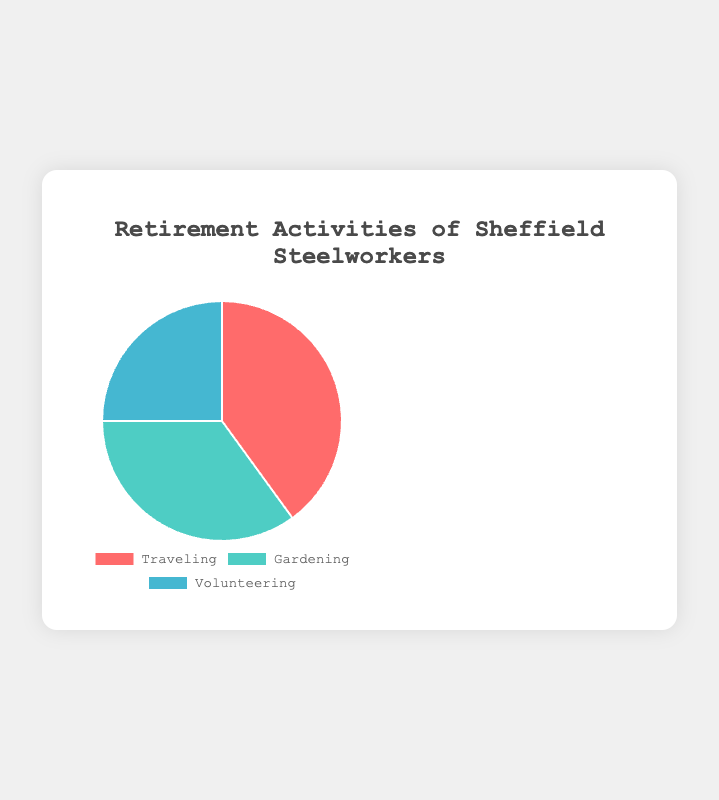Which activity is most popular among retired steelworkers? From the pie chart, the largest section is the one labeled "Traveling", which represents the highest percentage at 40%.
Answer: Traveling Which activity is least popular among retired steelworkers? The smallest section of the pie chart is labeled "Volunteering", which represents the lowest percentage at 25%.
Answer: Volunteering How many more percentage points is Traveling compared to Volunteering? Traveling is at 40% and Volunteering is at 25%. The difference is 40% - 25% = 15%.
Answer: 15% Is the percentage of people gardening greater than those volunteering? Yes, the percentage of people gardening (35%) is greater than those volunteering (25%).
Answer: Yes What is the sum of percentages for Gardening and Volunteering? Gardening is 35% and Volunteering is 25%. Adding these gives 35% + 25% = 60%.
Answer: 60% Which activity categories are represented by a shade of green or blue? The colors associated with Gardening and Volunteering are green and blue respectively from the visual attributes in the pie chart.
Answer: Gardening, Volunteering Which two activities combined make up less than half of the retired steelworkers' preferences? Gardening and Volunteering combined are 35% + 25% = 60%, so the pair with less than half is Traveling and Volunteering with 40% + 25% = 65%. The only combination less than half is by single gardening, so 35%.
Answer: None; All pair combinations exceed half Is Gardening closer in percentage to Traveling or Volunteering? The difference between Gardening (35%) and Traveling (40%) is 5%, whereas the difference between Gardening (35%) and Volunteering (25%) is 10%. Therefore, Gardening is closer to Traveling.
Answer: Traveling 